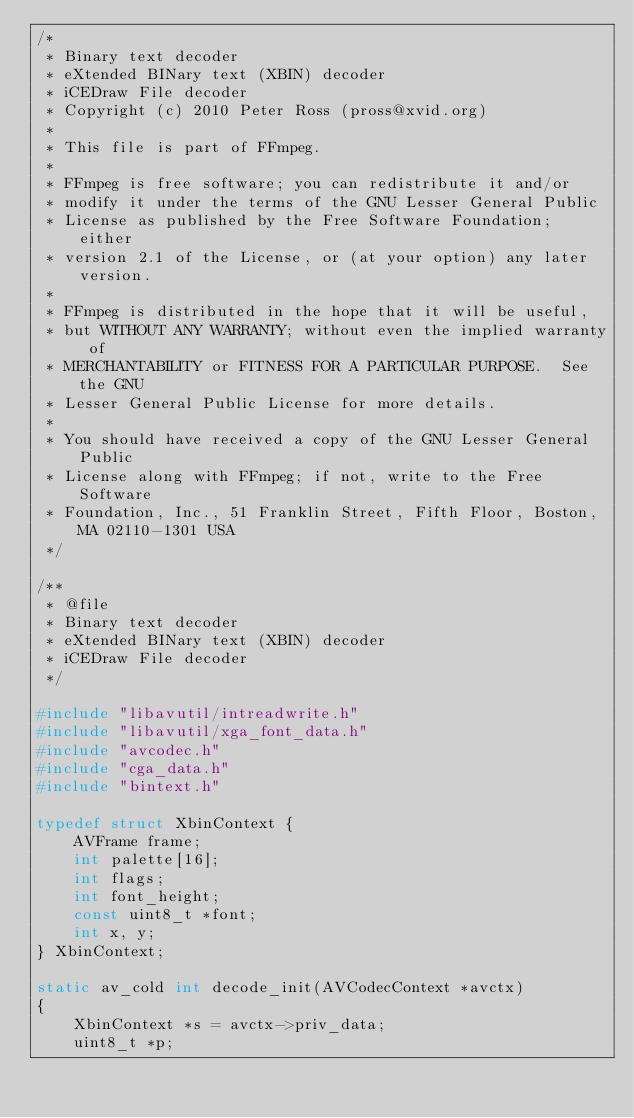<code> <loc_0><loc_0><loc_500><loc_500><_C_>/*
 * Binary text decoder
 * eXtended BINary text (XBIN) decoder
 * iCEDraw File decoder
 * Copyright (c) 2010 Peter Ross (pross@xvid.org)
 *
 * This file is part of FFmpeg.
 *
 * FFmpeg is free software; you can redistribute it and/or
 * modify it under the terms of the GNU Lesser General Public
 * License as published by the Free Software Foundation; either
 * version 2.1 of the License, or (at your option) any later version.
 *
 * FFmpeg is distributed in the hope that it will be useful,
 * but WITHOUT ANY WARRANTY; without even the implied warranty of
 * MERCHANTABILITY or FITNESS FOR A PARTICULAR PURPOSE.  See the GNU
 * Lesser General Public License for more details.
 *
 * You should have received a copy of the GNU Lesser General Public
 * License along with FFmpeg; if not, write to the Free Software
 * Foundation, Inc., 51 Franklin Street, Fifth Floor, Boston, MA 02110-1301 USA
 */

/**
 * @file
 * Binary text decoder
 * eXtended BINary text (XBIN) decoder
 * iCEDraw File decoder
 */

#include "libavutil/intreadwrite.h"
#include "libavutil/xga_font_data.h"
#include "avcodec.h"
#include "cga_data.h"
#include "bintext.h"

typedef struct XbinContext {
    AVFrame frame;
    int palette[16];
    int flags;
    int font_height;
    const uint8_t *font;
    int x, y;
} XbinContext;

static av_cold int decode_init(AVCodecContext *avctx)
{
    XbinContext *s = avctx->priv_data;
    uint8_t *p;</code> 